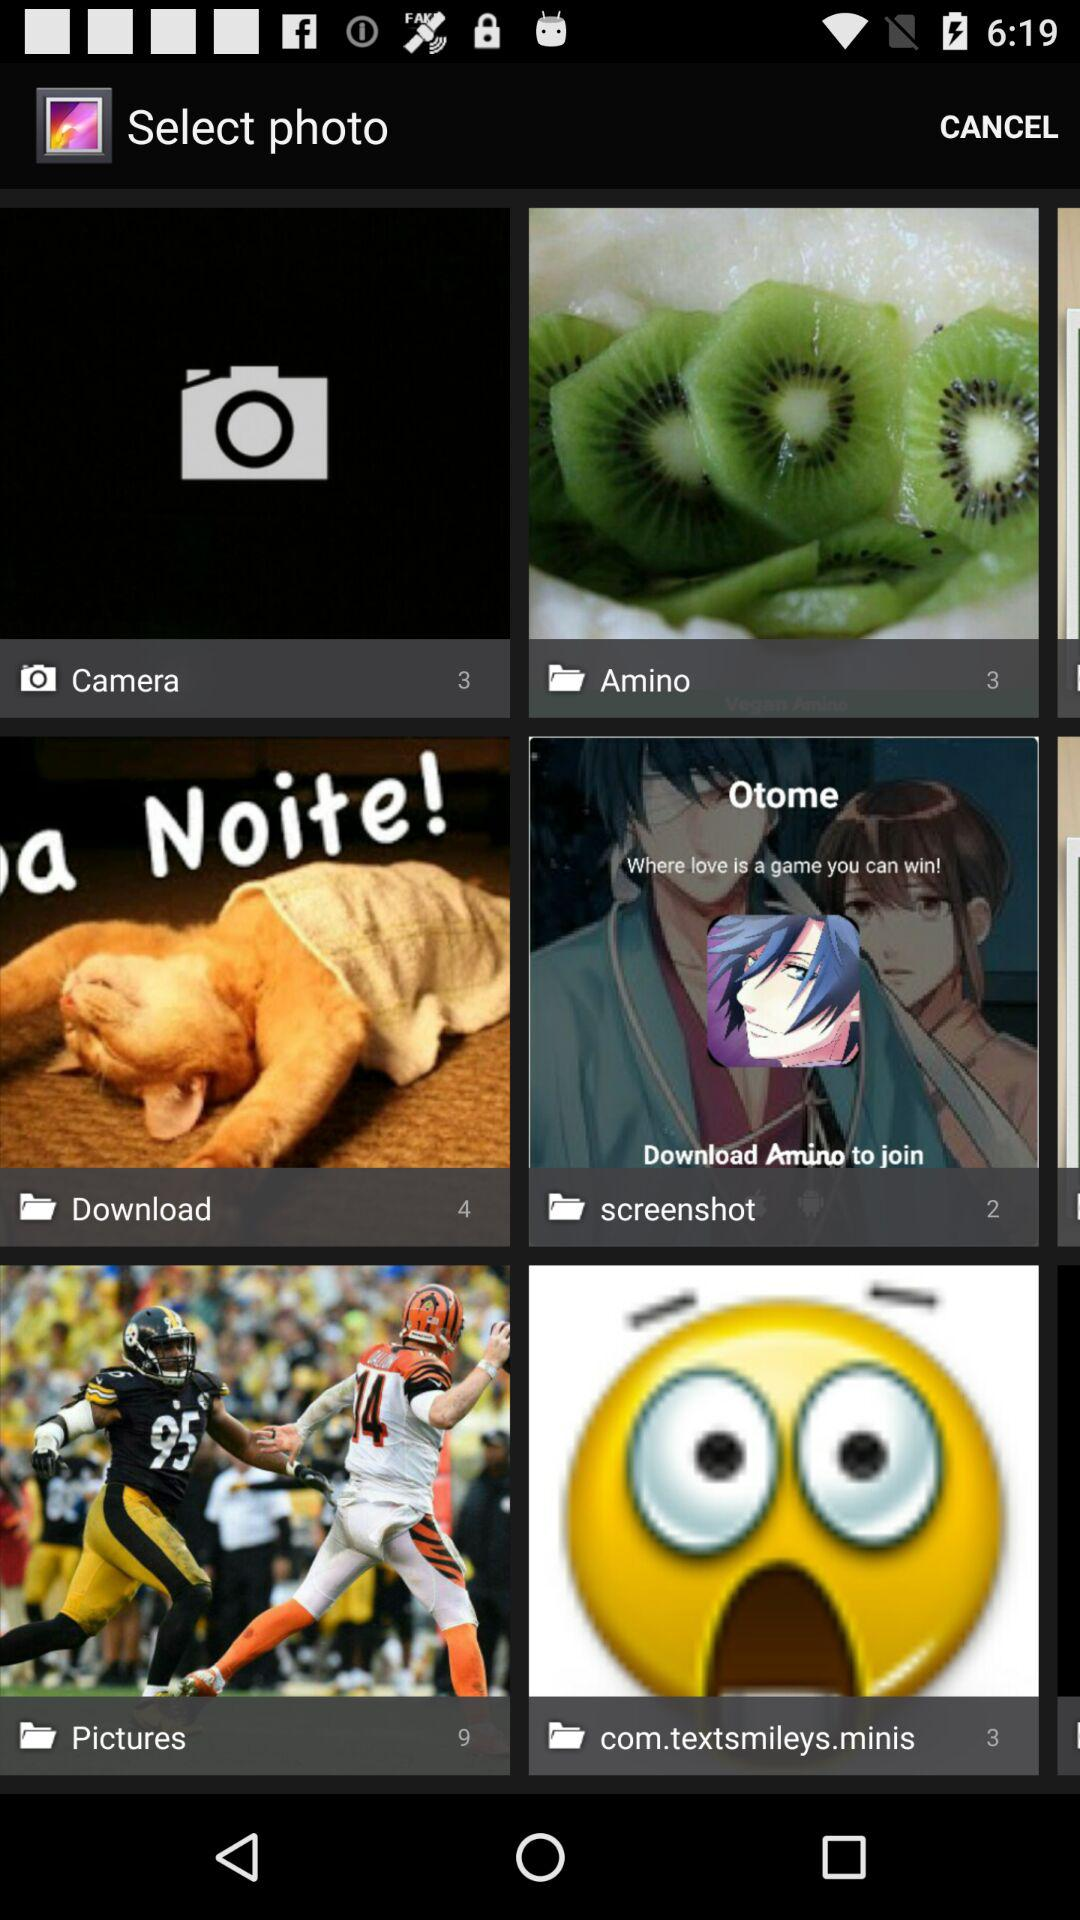How many photos are there in "Download"? There are 4 photos in "Download". 